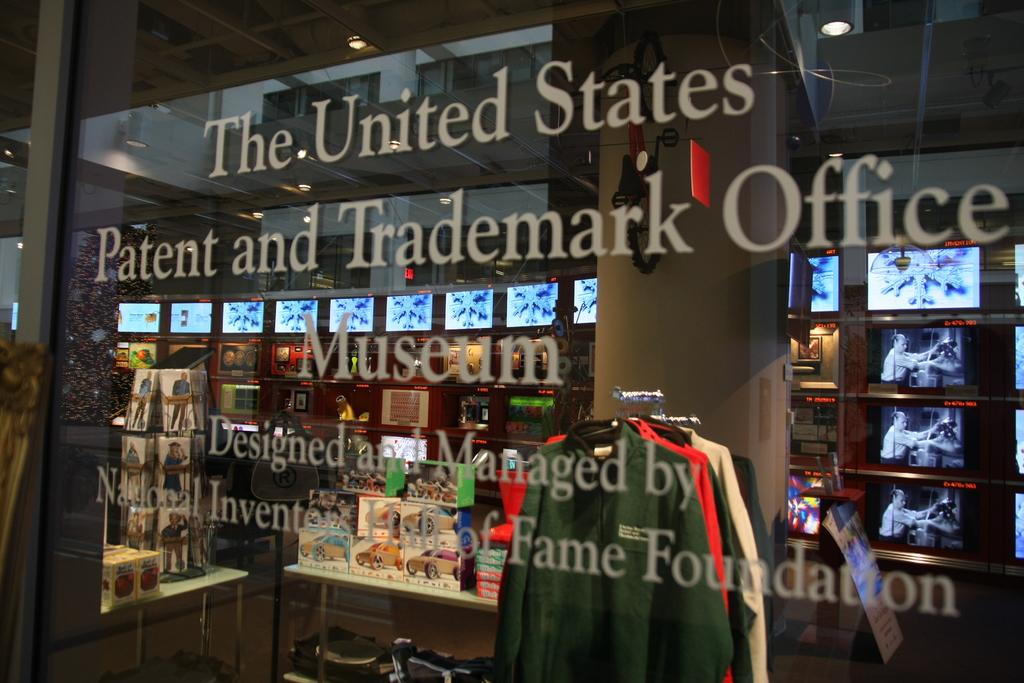Provide a one-sentence caption for the provided image. A window of The United States Patent and Trademark Office Museum. 